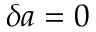<formula> <loc_0><loc_0><loc_500><loc_500>\delta a = 0</formula> 